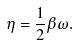<formula> <loc_0><loc_0><loc_500><loc_500>\eta = \frac { 1 } { 2 } \beta \omega .</formula> 